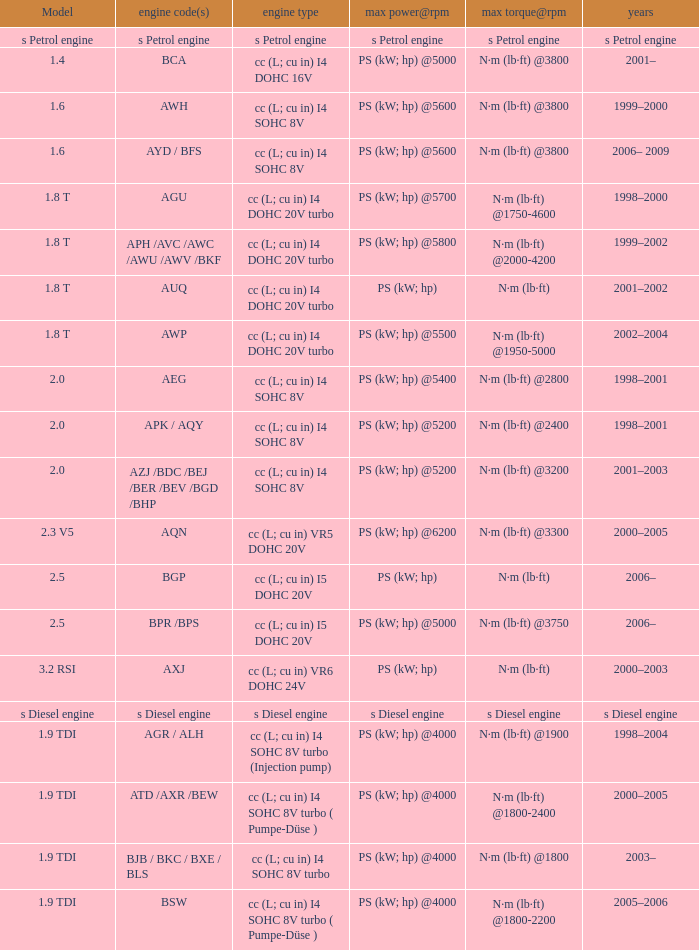What was the max torque@rpm of the engine which had the model 2.5  and a max power@rpm of ps (kw; hp) @5000? N·m (lb·ft) @3750. 